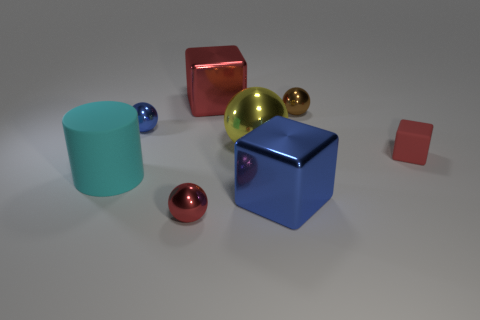What can you infer about the shapes and their arrangement? The objects are a mix of geometric forms: spheres, cubes, and a cylinder. They are placed in what seems to be a random arrangement, with varying distances between them. The variation in size and color helps create a visually engaging composition, possibly intended to showcase the contrast between shapes and colors. 